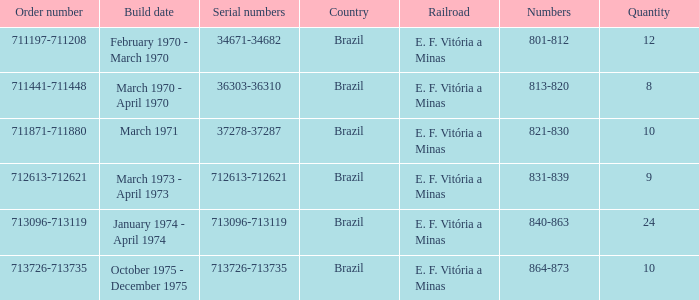What are the figures for the sequence of order numbers between 713096 and 713119? 840-863. 